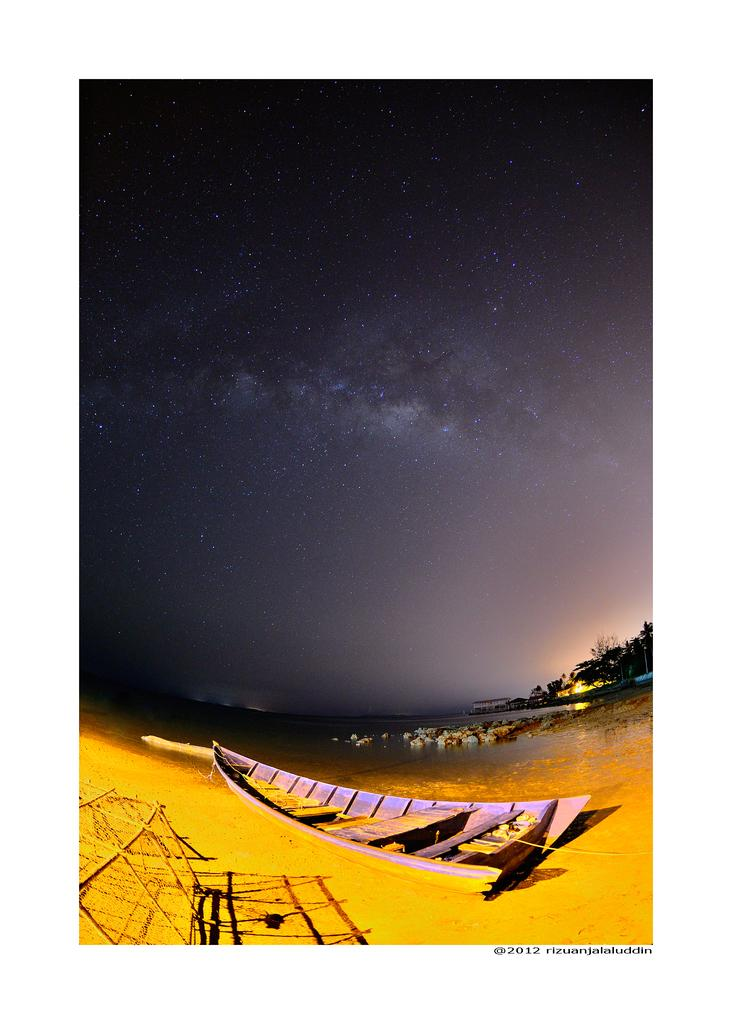What type of vehicles can be seen on the seashore in the image? There are boats on the seashore in the image. What is the main feature of the landscape in the image? There is a large water body in the image. What type of vegetation is present in the image? There is a group of trees in the image. What type of structure can be seen in the image? There is a building in the image. What celestial objects are visible in the image? The stars are visible in the image. How would you describe the weather in the image? The sky appears cloudy in the image. What type of shirt is being worn by the cable in the image? There is no cable or shirt present in the image. How many pages are visible in the image? There are no pages present in the image. 